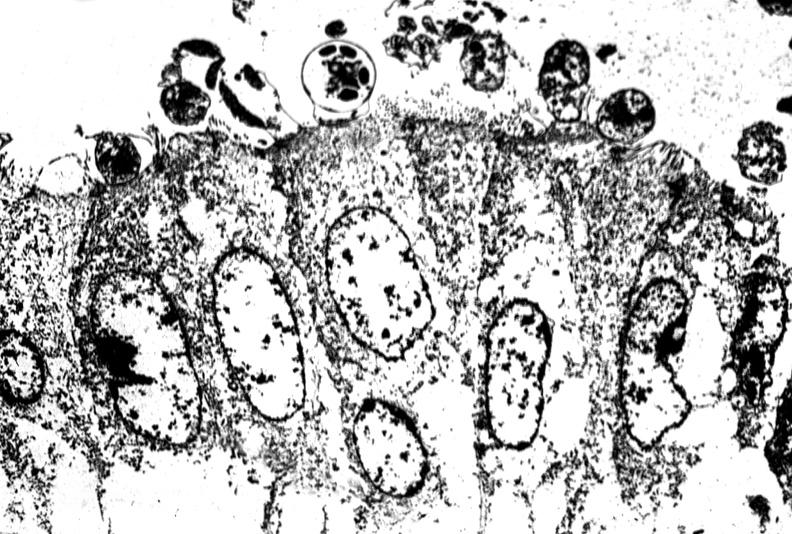what does this image show?
Answer the question using a single word or phrase. Colon biopsy 